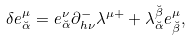<formula> <loc_0><loc_0><loc_500><loc_500>\delta e _ { \breve { \alpha } } ^ { \mu } = e _ { \breve { \alpha } } ^ { \nu } \partial _ { h \nu } ^ { - } \lambda ^ { \mu + } + \lambda _ { \breve { \alpha } } ^ { \breve { \beta } } e _ { \breve { \beta } } ^ { \mu } ,</formula> 